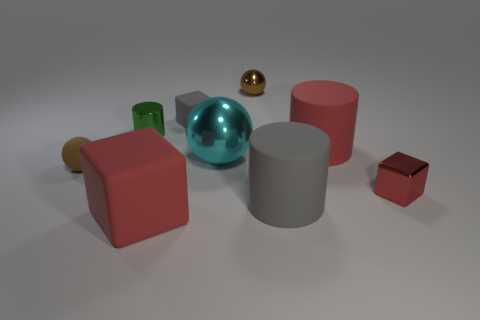Subtract all purple cubes. Subtract all cyan balls. How many cubes are left? 3 Subtract all spheres. How many objects are left? 6 Add 9 big cyan objects. How many big cyan objects are left? 10 Add 8 big cylinders. How many big cylinders exist? 10 Subtract 1 cyan balls. How many objects are left? 8 Subtract all blue cylinders. Subtract all tiny brown shiny balls. How many objects are left? 8 